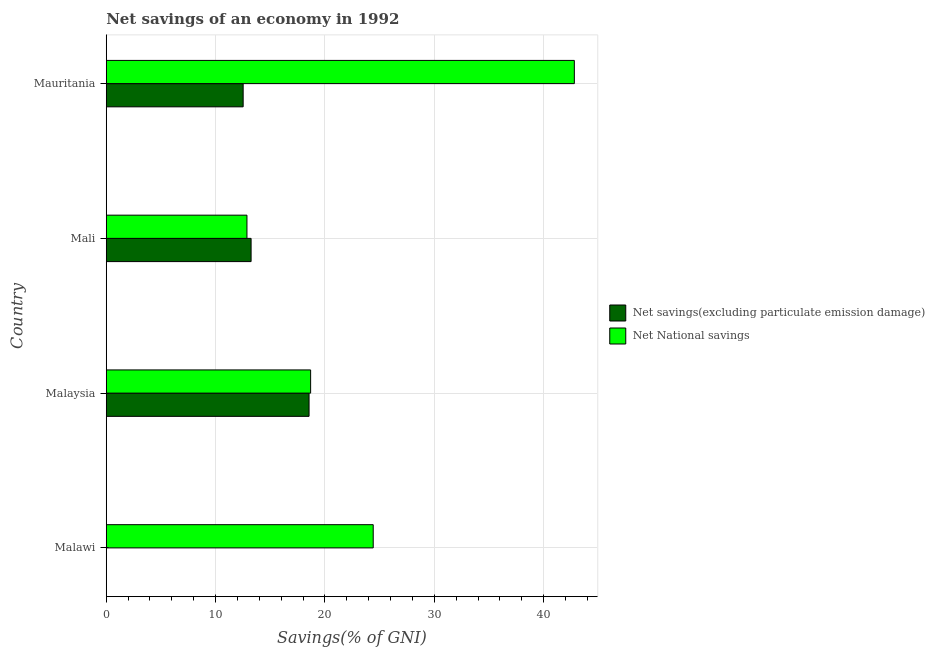How many bars are there on the 3rd tick from the top?
Provide a short and direct response. 2. How many bars are there on the 1st tick from the bottom?
Provide a succinct answer. 1. What is the label of the 2nd group of bars from the top?
Give a very brief answer. Mali. What is the net savings(excluding particulate emission damage) in Malaysia?
Your answer should be very brief. 18.55. Across all countries, what is the maximum net national savings?
Ensure brevity in your answer.  42.8. Across all countries, what is the minimum net national savings?
Ensure brevity in your answer.  12.87. In which country was the net national savings maximum?
Your response must be concise. Mauritania. What is the total net national savings in the graph?
Ensure brevity in your answer.  98.77. What is the difference between the net savings(excluding particulate emission damage) in Malaysia and that in Mali?
Offer a terse response. 5.3. What is the difference between the net national savings in Mali and the net savings(excluding particulate emission damage) in Mauritania?
Provide a short and direct response. 0.35. What is the average net national savings per country?
Your answer should be compact. 24.69. What is the difference between the net savings(excluding particulate emission damage) and net national savings in Mali?
Ensure brevity in your answer.  0.38. In how many countries, is the net national savings greater than 8 %?
Give a very brief answer. 4. What is the ratio of the net national savings in Malawi to that in Malaysia?
Your answer should be very brief. 1.31. Is the net savings(excluding particulate emission damage) in Malaysia less than that in Mauritania?
Give a very brief answer. No. Is the difference between the net savings(excluding particulate emission damage) in Malaysia and Mauritania greater than the difference between the net national savings in Malaysia and Mauritania?
Provide a short and direct response. Yes. What is the difference between the highest and the lowest net national savings?
Ensure brevity in your answer.  29.94. How many bars are there?
Provide a succinct answer. 7. How many countries are there in the graph?
Provide a succinct answer. 4. What is the difference between two consecutive major ticks on the X-axis?
Give a very brief answer. 10. Does the graph contain any zero values?
Ensure brevity in your answer.  Yes. Does the graph contain grids?
Give a very brief answer. Yes. Where does the legend appear in the graph?
Offer a terse response. Center right. How many legend labels are there?
Ensure brevity in your answer.  2. How are the legend labels stacked?
Keep it short and to the point. Vertical. What is the title of the graph?
Provide a succinct answer. Net savings of an economy in 1992. Does "Death rate" appear as one of the legend labels in the graph?
Provide a succinct answer. No. What is the label or title of the X-axis?
Provide a succinct answer. Savings(% of GNI). What is the Savings(% of GNI) of Net National savings in Malawi?
Provide a succinct answer. 24.41. What is the Savings(% of GNI) in Net savings(excluding particulate emission damage) in Malaysia?
Offer a terse response. 18.55. What is the Savings(% of GNI) in Net National savings in Malaysia?
Provide a succinct answer. 18.69. What is the Savings(% of GNI) of Net savings(excluding particulate emission damage) in Mali?
Offer a very short reply. 13.25. What is the Savings(% of GNI) of Net National savings in Mali?
Provide a short and direct response. 12.87. What is the Savings(% of GNI) of Net savings(excluding particulate emission damage) in Mauritania?
Your response must be concise. 12.52. What is the Savings(% of GNI) of Net National savings in Mauritania?
Your answer should be very brief. 42.8. Across all countries, what is the maximum Savings(% of GNI) of Net savings(excluding particulate emission damage)?
Your response must be concise. 18.55. Across all countries, what is the maximum Savings(% of GNI) in Net National savings?
Your answer should be compact. 42.8. Across all countries, what is the minimum Savings(% of GNI) of Net National savings?
Your response must be concise. 12.87. What is the total Savings(% of GNI) of Net savings(excluding particulate emission damage) in the graph?
Give a very brief answer. 44.31. What is the total Savings(% of GNI) in Net National savings in the graph?
Offer a terse response. 98.77. What is the difference between the Savings(% of GNI) in Net National savings in Malawi and that in Malaysia?
Offer a terse response. 5.72. What is the difference between the Savings(% of GNI) in Net National savings in Malawi and that in Mali?
Your answer should be very brief. 11.55. What is the difference between the Savings(% of GNI) in Net National savings in Malawi and that in Mauritania?
Offer a very short reply. -18.39. What is the difference between the Savings(% of GNI) of Net National savings in Malaysia and that in Mali?
Offer a very short reply. 5.82. What is the difference between the Savings(% of GNI) of Net savings(excluding particulate emission damage) in Malaysia and that in Mauritania?
Give a very brief answer. 6.03. What is the difference between the Savings(% of GNI) in Net National savings in Malaysia and that in Mauritania?
Give a very brief answer. -24.12. What is the difference between the Savings(% of GNI) of Net savings(excluding particulate emission damage) in Mali and that in Mauritania?
Offer a terse response. 0.73. What is the difference between the Savings(% of GNI) of Net National savings in Mali and that in Mauritania?
Make the answer very short. -29.94. What is the difference between the Savings(% of GNI) in Net savings(excluding particulate emission damage) in Malaysia and the Savings(% of GNI) in Net National savings in Mali?
Offer a very short reply. 5.68. What is the difference between the Savings(% of GNI) in Net savings(excluding particulate emission damage) in Malaysia and the Savings(% of GNI) in Net National savings in Mauritania?
Offer a very short reply. -24.26. What is the difference between the Savings(% of GNI) in Net savings(excluding particulate emission damage) in Mali and the Savings(% of GNI) in Net National savings in Mauritania?
Keep it short and to the point. -29.56. What is the average Savings(% of GNI) of Net savings(excluding particulate emission damage) per country?
Your answer should be very brief. 11.08. What is the average Savings(% of GNI) of Net National savings per country?
Ensure brevity in your answer.  24.69. What is the difference between the Savings(% of GNI) of Net savings(excluding particulate emission damage) and Savings(% of GNI) of Net National savings in Malaysia?
Provide a short and direct response. -0.14. What is the difference between the Savings(% of GNI) in Net savings(excluding particulate emission damage) and Savings(% of GNI) in Net National savings in Mali?
Your answer should be very brief. 0.38. What is the difference between the Savings(% of GNI) of Net savings(excluding particulate emission damage) and Savings(% of GNI) of Net National savings in Mauritania?
Give a very brief answer. -30.28. What is the ratio of the Savings(% of GNI) in Net National savings in Malawi to that in Malaysia?
Your answer should be compact. 1.31. What is the ratio of the Savings(% of GNI) of Net National savings in Malawi to that in Mali?
Your answer should be compact. 1.9. What is the ratio of the Savings(% of GNI) of Net National savings in Malawi to that in Mauritania?
Your response must be concise. 0.57. What is the ratio of the Savings(% of GNI) in Net savings(excluding particulate emission damage) in Malaysia to that in Mali?
Your response must be concise. 1.4. What is the ratio of the Savings(% of GNI) in Net National savings in Malaysia to that in Mali?
Your answer should be very brief. 1.45. What is the ratio of the Savings(% of GNI) in Net savings(excluding particulate emission damage) in Malaysia to that in Mauritania?
Your answer should be compact. 1.48. What is the ratio of the Savings(% of GNI) of Net National savings in Malaysia to that in Mauritania?
Keep it short and to the point. 0.44. What is the ratio of the Savings(% of GNI) in Net savings(excluding particulate emission damage) in Mali to that in Mauritania?
Keep it short and to the point. 1.06. What is the ratio of the Savings(% of GNI) in Net National savings in Mali to that in Mauritania?
Offer a very short reply. 0.3. What is the difference between the highest and the second highest Savings(% of GNI) of Net National savings?
Make the answer very short. 18.39. What is the difference between the highest and the lowest Savings(% of GNI) in Net savings(excluding particulate emission damage)?
Your response must be concise. 18.55. What is the difference between the highest and the lowest Savings(% of GNI) in Net National savings?
Offer a very short reply. 29.94. 